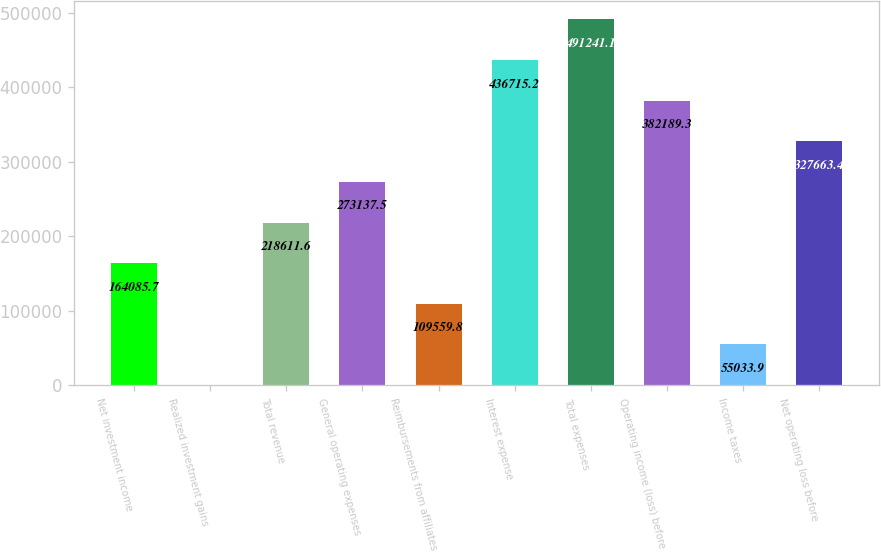Convert chart to OTSL. <chart><loc_0><loc_0><loc_500><loc_500><bar_chart><fcel>Net investment income<fcel>Realized investment gains<fcel>Total revenue<fcel>General operating expenses<fcel>Reimbursements from affiliates<fcel>Interest expense<fcel>Total expenses<fcel>Operating income (loss) before<fcel>Income taxes<fcel>Net operating loss before<nl><fcel>164086<fcel>508<fcel>218612<fcel>273138<fcel>109560<fcel>436715<fcel>491241<fcel>382189<fcel>55033.9<fcel>327663<nl></chart> 